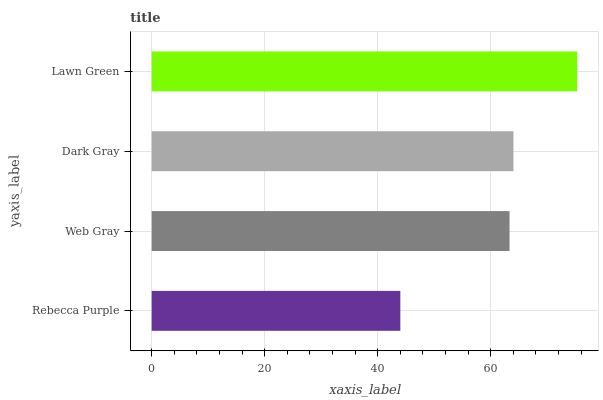Is Rebecca Purple the minimum?
Answer yes or no. Yes. Is Lawn Green the maximum?
Answer yes or no. Yes. Is Web Gray the minimum?
Answer yes or no. No. Is Web Gray the maximum?
Answer yes or no. No. Is Web Gray greater than Rebecca Purple?
Answer yes or no. Yes. Is Rebecca Purple less than Web Gray?
Answer yes or no. Yes. Is Rebecca Purple greater than Web Gray?
Answer yes or no. No. Is Web Gray less than Rebecca Purple?
Answer yes or no. No. Is Dark Gray the high median?
Answer yes or no. Yes. Is Web Gray the low median?
Answer yes or no. Yes. Is Rebecca Purple the high median?
Answer yes or no. No. Is Lawn Green the low median?
Answer yes or no. No. 